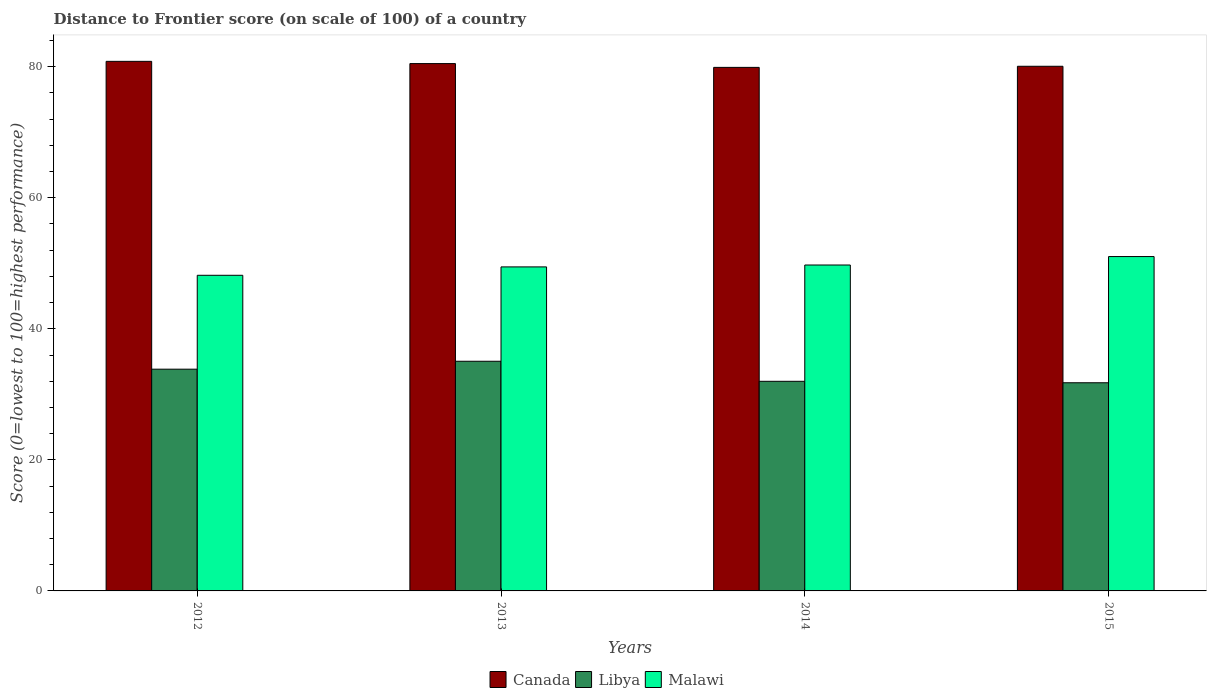How many different coloured bars are there?
Your answer should be very brief. 3. Are the number of bars per tick equal to the number of legend labels?
Make the answer very short. Yes. Are the number of bars on each tick of the X-axis equal?
Ensure brevity in your answer.  Yes. How many bars are there on the 2nd tick from the left?
Your response must be concise. 3. How many bars are there on the 2nd tick from the right?
Make the answer very short. 3. What is the label of the 3rd group of bars from the left?
Make the answer very short. 2014. In how many cases, is the number of bars for a given year not equal to the number of legend labels?
Give a very brief answer. 0. What is the distance to frontier score of in Malawi in 2014?
Offer a terse response. 49.74. Across all years, what is the maximum distance to frontier score of in Libya?
Ensure brevity in your answer.  35.05. Across all years, what is the minimum distance to frontier score of in Canada?
Your answer should be very brief. 79.9. In which year was the distance to frontier score of in Malawi maximum?
Keep it short and to the point. 2015. What is the total distance to frontier score of in Libya in the graph?
Offer a very short reply. 132.65. What is the difference between the distance to frontier score of in Libya in 2012 and that in 2015?
Give a very brief answer. 2.07. What is the difference between the distance to frontier score of in Malawi in 2015 and the distance to frontier score of in Libya in 2012?
Offer a very short reply. 17.19. What is the average distance to frontier score of in Canada per year?
Make the answer very short. 80.32. In the year 2013, what is the difference between the distance to frontier score of in Libya and distance to frontier score of in Canada?
Your answer should be compact. -45.43. In how many years, is the distance to frontier score of in Libya greater than 32?
Provide a succinct answer. 2. What is the ratio of the distance to frontier score of in Libya in 2013 to that in 2014?
Provide a succinct answer. 1.1. What is the difference between the highest and the second highest distance to frontier score of in Libya?
Keep it short and to the point. 1.21. What is the difference between the highest and the lowest distance to frontier score of in Canada?
Keep it short and to the point. 0.92. What does the 3rd bar from the left in 2012 represents?
Provide a short and direct response. Malawi. What does the 1st bar from the right in 2014 represents?
Your response must be concise. Malawi. Is it the case that in every year, the sum of the distance to frontier score of in Canada and distance to frontier score of in Libya is greater than the distance to frontier score of in Malawi?
Keep it short and to the point. Yes. How many bars are there?
Your answer should be compact. 12. How many years are there in the graph?
Provide a short and direct response. 4. Are the values on the major ticks of Y-axis written in scientific E-notation?
Your answer should be very brief. No. Does the graph contain any zero values?
Offer a terse response. No. Does the graph contain grids?
Your response must be concise. No. Where does the legend appear in the graph?
Your answer should be very brief. Bottom center. What is the title of the graph?
Offer a terse response. Distance to Frontier score (on scale of 100) of a country. Does "Australia" appear as one of the legend labels in the graph?
Ensure brevity in your answer.  No. What is the label or title of the X-axis?
Provide a succinct answer. Years. What is the label or title of the Y-axis?
Keep it short and to the point. Score (0=lowest to 100=highest performance). What is the Score (0=lowest to 100=highest performance) of Canada in 2012?
Offer a terse response. 80.82. What is the Score (0=lowest to 100=highest performance) in Libya in 2012?
Provide a short and direct response. 33.84. What is the Score (0=lowest to 100=highest performance) in Malawi in 2012?
Your answer should be compact. 48.17. What is the Score (0=lowest to 100=highest performance) of Canada in 2013?
Offer a very short reply. 80.48. What is the Score (0=lowest to 100=highest performance) of Libya in 2013?
Your answer should be very brief. 35.05. What is the Score (0=lowest to 100=highest performance) in Malawi in 2013?
Offer a very short reply. 49.45. What is the Score (0=lowest to 100=highest performance) in Canada in 2014?
Make the answer very short. 79.9. What is the Score (0=lowest to 100=highest performance) in Libya in 2014?
Make the answer very short. 31.99. What is the Score (0=lowest to 100=highest performance) in Malawi in 2014?
Your response must be concise. 49.74. What is the Score (0=lowest to 100=highest performance) of Canada in 2015?
Offer a very short reply. 80.07. What is the Score (0=lowest to 100=highest performance) of Libya in 2015?
Make the answer very short. 31.77. What is the Score (0=lowest to 100=highest performance) of Malawi in 2015?
Offer a very short reply. 51.03. Across all years, what is the maximum Score (0=lowest to 100=highest performance) of Canada?
Your response must be concise. 80.82. Across all years, what is the maximum Score (0=lowest to 100=highest performance) in Libya?
Provide a succinct answer. 35.05. Across all years, what is the maximum Score (0=lowest to 100=highest performance) in Malawi?
Ensure brevity in your answer.  51.03. Across all years, what is the minimum Score (0=lowest to 100=highest performance) of Canada?
Your response must be concise. 79.9. Across all years, what is the minimum Score (0=lowest to 100=highest performance) of Libya?
Your answer should be very brief. 31.77. Across all years, what is the minimum Score (0=lowest to 100=highest performance) in Malawi?
Your response must be concise. 48.17. What is the total Score (0=lowest to 100=highest performance) of Canada in the graph?
Make the answer very short. 321.27. What is the total Score (0=lowest to 100=highest performance) in Libya in the graph?
Provide a short and direct response. 132.65. What is the total Score (0=lowest to 100=highest performance) in Malawi in the graph?
Give a very brief answer. 198.39. What is the difference between the Score (0=lowest to 100=highest performance) in Canada in 2012 and that in 2013?
Offer a very short reply. 0.34. What is the difference between the Score (0=lowest to 100=highest performance) in Libya in 2012 and that in 2013?
Offer a very short reply. -1.21. What is the difference between the Score (0=lowest to 100=highest performance) in Malawi in 2012 and that in 2013?
Provide a short and direct response. -1.28. What is the difference between the Score (0=lowest to 100=highest performance) of Canada in 2012 and that in 2014?
Give a very brief answer. 0.92. What is the difference between the Score (0=lowest to 100=highest performance) in Libya in 2012 and that in 2014?
Offer a very short reply. 1.85. What is the difference between the Score (0=lowest to 100=highest performance) of Malawi in 2012 and that in 2014?
Make the answer very short. -1.57. What is the difference between the Score (0=lowest to 100=highest performance) in Canada in 2012 and that in 2015?
Your response must be concise. 0.75. What is the difference between the Score (0=lowest to 100=highest performance) of Libya in 2012 and that in 2015?
Provide a succinct answer. 2.07. What is the difference between the Score (0=lowest to 100=highest performance) of Malawi in 2012 and that in 2015?
Provide a short and direct response. -2.86. What is the difference between the Score (0=lowest to 100=highest performance) of Canada in 2013 and that in 2014?
Your answer should be compact. 0.58. What is the difference between the Score (0=lowest to 100=highest performance) in Libya in 2013 and that in 2014?
Make the answer very short. 3.06. What is the difference between the Score (0=lowest to 100=highest performance) of Malawi in 2013 and that in 2014?
Your answer should be very brief. -0.29. What is the difference between the Score (0=lowest to 100=highest performance) of Canada in 2013 and that in 2015?
Your answer should be compact. 0.41. What is the difference between the Score (0=lowest to 100=highest performance) of Libya in 2013 and that in 2015?
Your response must be concise. 3.28. What is the difference between the Score (0=lowest to 100=highest performance) in Malawi in 2013 and that in 2015?
Offer a very short reply. -1.58. What is the difference between the Score (0=lowest to 100=highest performance) of Canada in 2014 and that in 2015?
Offer a very short reply. -0.17. What is the difference between the Score (0=lowest to 100=highest performance) of Libya in 2014 and that in 2015?
Make the answer very short. 0.22. What is the difference between the Score (0=lowest to 100=highest performance) of Malawi in 2014 and that in 2015?
Your response must be concise. -1.29. What is the difference between the Score (0=lowest to 100=highest performance) of Canada in 2012 and the Score (0=lowest to 100=highest performance) of Libya in 2013?
Offer a very short reply. 45.77. What is the difference between the Score (0=lowest to 100=highest performance) in Canada in 2012 and the Score (0=lowest to 100=highest performance) in Malawi in 2013?
Your response must be concise. 31.37. What is the difference between the Score (0=lowest to 100=highest performance) in Libya in 2012 and the Score (0=lowest to 100=highest performance) in Malawi in 2013?
Keep it short and to the point. -15.61. What is the difference between the Score (0=lowest to 100=highest performance) of Canada in 2012 and the Score (0=lowest to 100=highest performance) of Libya in 2014?
Keep it short and to the point. 48.83. What is the difference between the Score (0=lowest to 100=highest performance) of Canada in 2012 and the Score (0=lowest to 100=highest performance) of Malawi in 2014?
Offer a terse response. 31.08. What is the difference between the Score (0=lowest to 100=highest performance) in Libya in 2012 and the Score (0=lowest to 100=highest performance) in Malawi in 2014?
Make the answer very short. -15.9. What is the difference between the Score (0=lowest to 100=highest performance) in Canada in 2012 and the Score (0=lowest to 100=highest performance) in Libya in 2015?
Provide a succinct answer. 49.05. What is the difference between the Score (0=lowest to 100=highest performance) of Canada in 2012 and the Score (0=lowest to 100=highest performance) of Malawi in 2015?
Ensure brevity in your answer.  29.79. What is the difference between the Score (0=lowest to 100=highest performance) in Libya in 2012 and the Score (0=lowest to 100=highest performance) in Malawi in 2015?
Provide a short and direct response. -17.19. What is the difference between the Score (0=lowest to 100=highest performance) of Canada in 2013 and the Score (0=lowest to 100=highest performance) of Libya in 2014?
Give a very brief answer. 48.49. What is the difference between the Score (0=lowest to 100=highest performance) in Canada in 2013 and the Score (0=lowest to 100=highest performance) in Malawi in 2014?
Your answer should be compact. 30.74. What is the difference between the Score (0=lowest to 100=highest performance) of Libya in 2013 and the Score (0=lowest to 100=highest performance) of Malawi in 2014?
Offer a very short reply. -14.69. What is the difference between the Score (0=lowest to 100=highest performance) of Canada in 2013 and the Score (0=lowest to 100=highest performance) of Libya in 2015?
Your response must be concise. 48.71. What is the difference between the Score (0=lowest to 100=highest performance) of Canada in 2013 and the Score (0=lowest to 100=highest performance) of Malawi in 2015?
Your response must be concise. 29.45. What is the difference between the Score (0=lowest to 100=highest performance) of Libya in 2013 and the Score (0=lowest to 100=highest performance) of Malawi in 2015?
Provide a short and direct response. -15.98. What is the difference between the Score (0=lowest to 100=highest performance) of Canada in 2014 and the Score (0=lowest to 100=highest performance) of Libya in 2015?
Provide a succinct answer. 48.13. What is the difference between the Score (0=lowest to 100=highest performance) of Canada in 2014 and the Score (0=lowest to 100=highest performance) of Malawi in 2015?
Provide a succinct answer. 28.87. What is the difference between the Score (0=lowest to 100=highest performance) in Libya in 2014 and the Score (0=lowest to 100=highest performance) in Malawi in 2015?
Offer a terse response. -19.04. What is the average Score (0=lowest to 100=highest performance) of Canada per year?
Your response must be concise. 80.32. What is the average Score (0=lowest to 100=highest performance) of Libya per year?
Offer a terse response. 33.16. What is the average Score (0=lowest to 100=highest performance) in Malawi per year?
Ensure brevity in your answer.  49.6. In the year 2012, what is the difference between the Score (0=lowest to 100=highest performance) in Canada and Score (0=lowest to 100=highest performance) in Libya?
Offer a very short reply. 46.98. In the year 2012, what is the difference between the Score (0=lowest to 100=highest performance) of Canada and Score (0=lowest to 100=highest performance) of Malawi?
Provide a short and direct response. 32.65. In the year 2012, what is the difference between the Score (0=lowest to 100=highest performance) of Libya and Score (0=lowest to 100=highest performance) of Malawi?
Offer a terse response. -14.33. In the year 2013, what is the difference between the Score (0=lowest to 100=highest performance) in Canada and Score (0=lowest to 100=highest performance) in Libya?
Give a very brief answer. 45.43. In the year 2013, what is the difference between the Score (0=lowest to 100=highest performance) of Canada and Score (0=lowest to 100=highest performance) of Malawi?
Keep it short and to the point. 31.03. In the year 2013, what is the difference between the Score (0=lowest to 100=highest performance) of Libya and Score (0=lowest to 100=highest performance) of Malawi?
Your answer should be very brief. -14.4. In the year 2014, what is the difference between the Score (0=lowest to 100=highest performance) of Canada and Score (0=lowest to 100=highest performance) of Libya?
Make the answer very short. 47.91. In the year 2014, what is the difference between the Score (0=lowest to 100=highest performance) of Canada and Score (0=lowest to 100=highest performance) of Malawi?
Ensure brevity in your answer.  30.16. In the year 2014, what is the difference between the Score (0=lowest to 100=highest performance) in Libya and Score (0=lowest to 100=highest performance) in Malawi?
Keep it short and to the point. -17.75. In the year 2015, what is the difference between the Score (0=lowest to 100=highest performance) of Canada and Score (0=lowest to 100=highest performance) of Libya?
Give a very brief answer. 48.3. In the year 2015, what is the difference between the Score (0=lowest to 100=highest performance) in Canada and Score (0=lowest to 100=highest performance) in Malawi?
Ensure brevity in your answer.  29.04. In the year 2015, what is the difference between the Score (0=lowest to 100=highest performance) in Libya and Score (0=lowest to 100=highest performance) in Malawi?
Offer a very short reply. -19.26. What is the ratio of the Score (0=lowest to 100=highest performance) in Canada in 2012 to that in 2013?
Give a very brief answer. 1. What is the ratio of the Score (0=lowest to 100=highest performance) in Libya in 2012 to that in 2013?
Ensure brevity in your answer.  0.97. What is the ratio of the Score (0=lowest to 100=highest performance) in Malawi in 2012 to that in 2013?
Offer a very short reply. 0.97. What is the ratio of the Score (0=lowest to 100=highest performance) of Canada in 2012 to that in 2014?
Provide a succinct answer. 1.01. What is the ratio of the Score (0=lowest to 100=highest performance) in Libya in 2012 to that in 2014?
Your answer should be compact. 1.06. What is the ratio of the Score (0=lowest to 100=highest performance) in Malawi in 2012 to that in 2014?
Keep it short and to the point. 0.97. What is the ratio of the Score (0=lowest to 100=highest performance) in Canada in 2012 to that in 2015?
Offer a very short reply. 1.01. What is the ratio of the Score (0=lowest to 100=highest performance) in Libya in 2012 to that in 2015?
Offer a very short reply. 1.07. What is the ratio of the Score (0=lowest to 100=highest performance) in Malawi in 2012 to that in 2015?
Offer a terse response. 0.94. What is the ratio of the Score (0=lowest to 100=highest performance) of Canada in 2013 to that in 2014?
Your response must be concise. 1.01. What is the ratio of the Score (0=lowest to 100=highest performance) of Libya in 2013 to that in 2014?
Offer a very short reply. 1.1. What is the ratio of the Score (0=lowest to 100=highest performance) in Malawi in 2013 to that in 2014?
Keep it short and to the point. 0.99. What is the ratio of the Score (0=lowest to 100=highest performance) of Libya in 2013 to that in 2015?
Offer a terse response. 1.1. What is the ratio of the Score (0=lowest to 100=highest performance) in Malawi in 2013 to that in 2015?
Provide a short and direct response. 0.97. What is the ratio of the Score (0=lowest to 100=highest performance) of Malawi in 2014 to that in 2015?
Provide a succinct answer. 0.97. What is the difference between the highest and the second highest Score (0=lowest to 100=highest performance) in Canada?
Make the answer very short. 0.34. What is the difference between the highest and the second highest Score (0=lowest to 100=highest performance) of Libya?
Your answer should be compact. 1.21. What is the difference between the highest and the second highest Score (0=lowest to 100=highest performance) in Malawi?
Keep it short and to the point. 1.29. What is the difference between the highest and the lowest Score (0=lowest to 100=highest performance) in Libya?
Your answer should be very brief. 3.28. What is the difference between the highest and the lowest Score (0=lowest to 100=highest performance) in Malawi?
Make the answer very short. 2.86. 